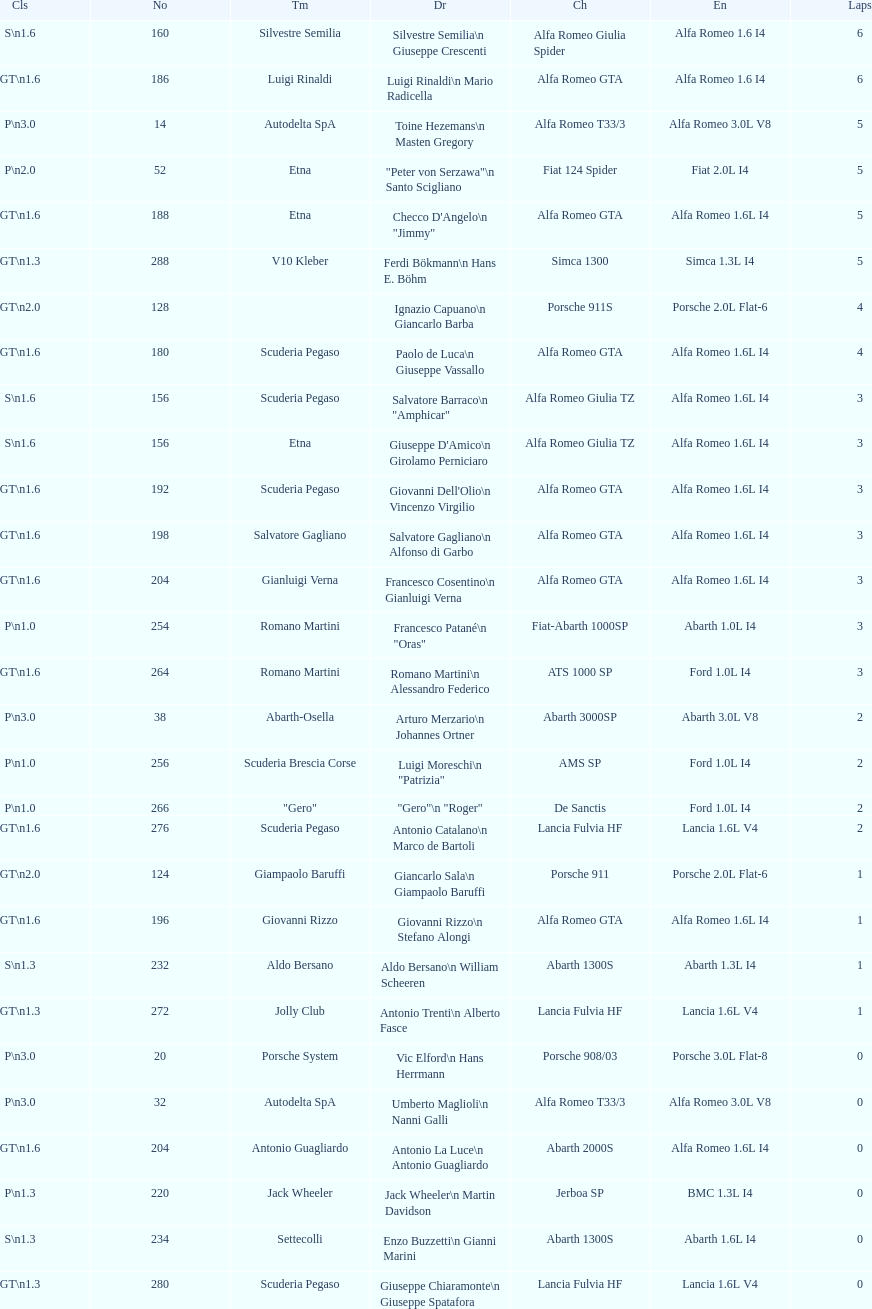Which chassis is in the middle of simca 1300 and alfa romeo gta? Porsche 911S. 